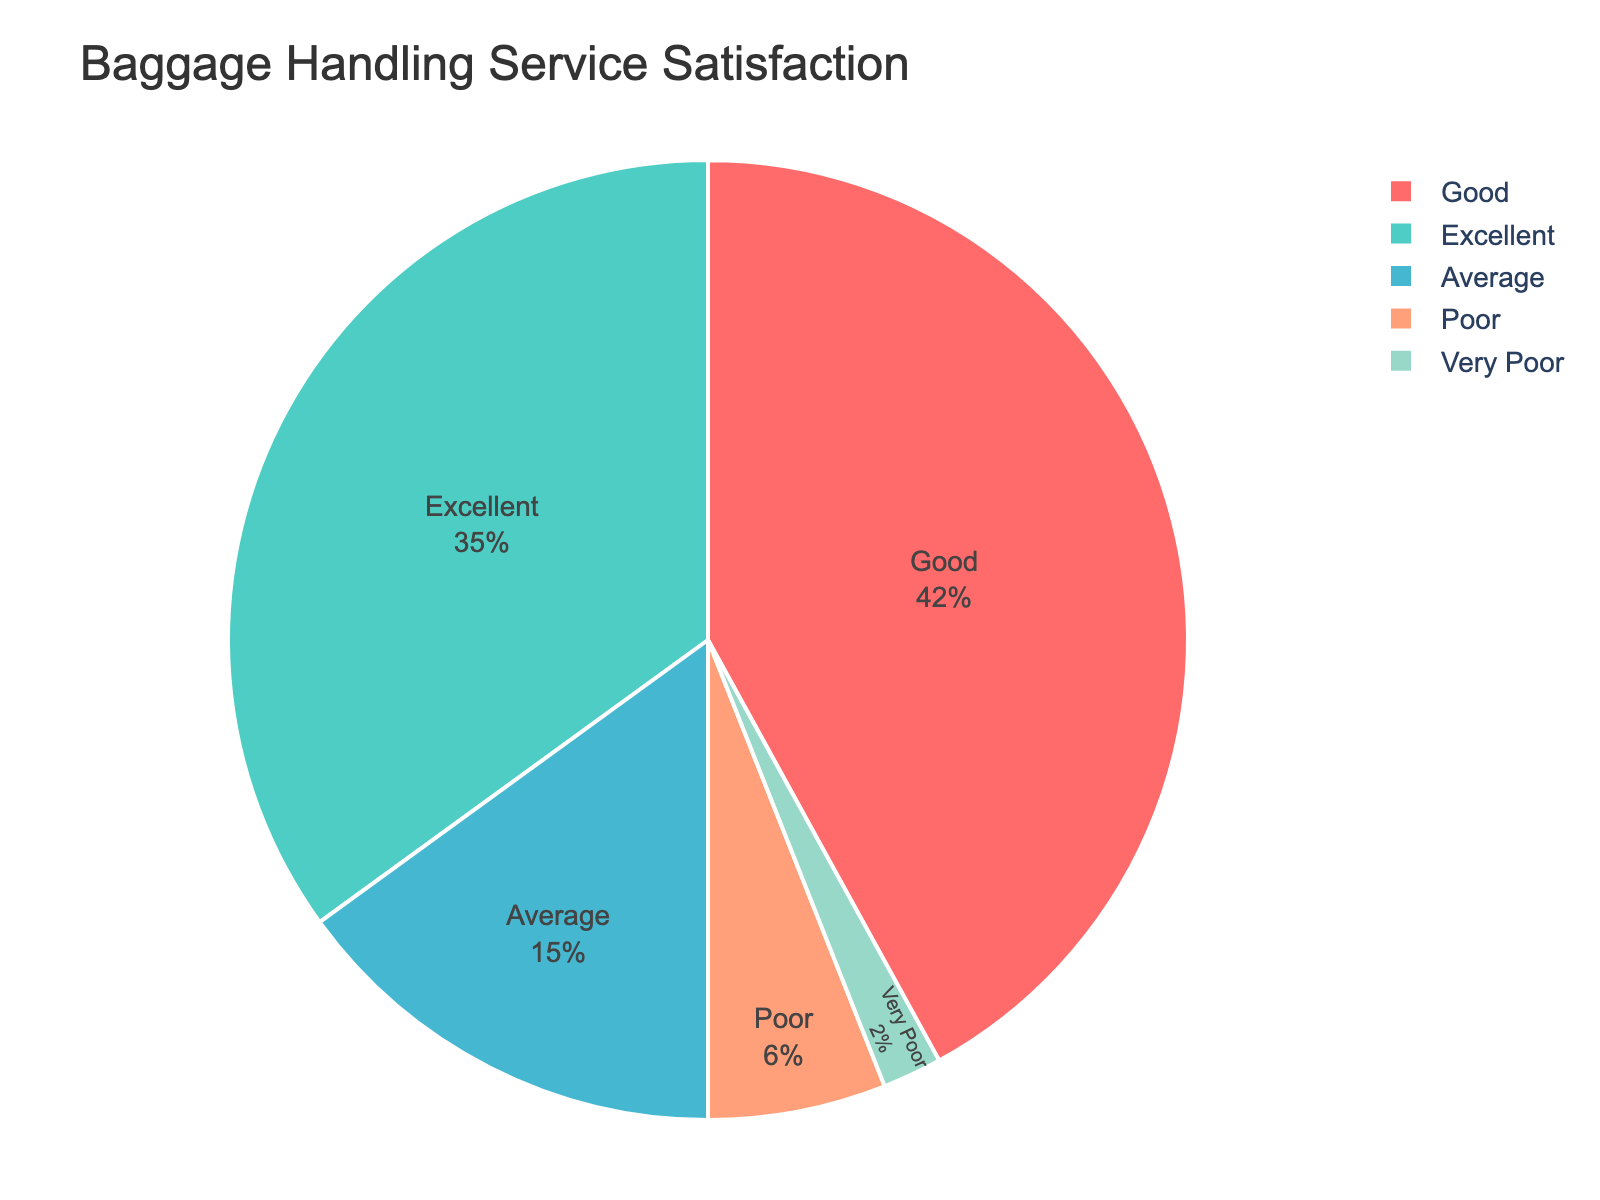What is the percentage of customers who rated the baggage handling service as 'Good'? The chart shows that the slice labeled 'Good' occupies 42% of the chart.
Answer: 42% Which rating category received the majority of the responses? By examining the chart, we see that the 'Good' category has the largest slice, making up 42% of the responses.
Answer: Good How much more percentage does 'Excellent' have compared to 'Poor'? The chart indicates 'Excellent' has 35% and 'Poor' has 6%. The difference is 35% - 6% = 29%.
Answer: 29% Combine the percentage of 'Average' and 'Poor' ratings. What do you get? The 'Average' rating is 15% and the 'Poor' rating is 6%. Adding them together, 15% + 6% = 21%.
Answer: 21% What is the sum of the percentages of 'Very Poor' and 'Poor' ratings? The chart shows 'Very Poor' as 2% and 'Poor' as 6%. Adding them together gives 2% + 6% = 8%.
Answer: 8% Which category has the smallest representation in the pie chart? The 'Very Poor' category occupies the smallest slice of the chart with 2%.
Answer: Very Poor Is the percentage of 'Excellent' ratings greater than 'Average' ratings? The chart shows 'Excellent' at 35% and 'Average' at 15%. Since 35% is greater than 15%, the answer is yes.
Answer: Yes What is the total percentage represented by the 'Excellent' and 'Good' ratings combined? According to the chart, 'Excellent' is 35% and 'Good' is 42%. Adding them together gives 35% + 42% = 77%.
Answer: 77% If you combine 'Poor' and 'Very Poor' categories, are they less than the 'Average' rating? Combining 'Poor' (6%) and 'Very Poor' (2%) gives 6% + 2% = 8%. The 'Average' rating is 15%, so 8% is less than 15%.
Answer: Yes What is the percentage of ratings that are either 'Good' or 'Average'? 'Good' ratings make up 42% and 'Average' ratings are 15%. Adding them together gives us 42% + 15% = 57%.
Answer: 57% 